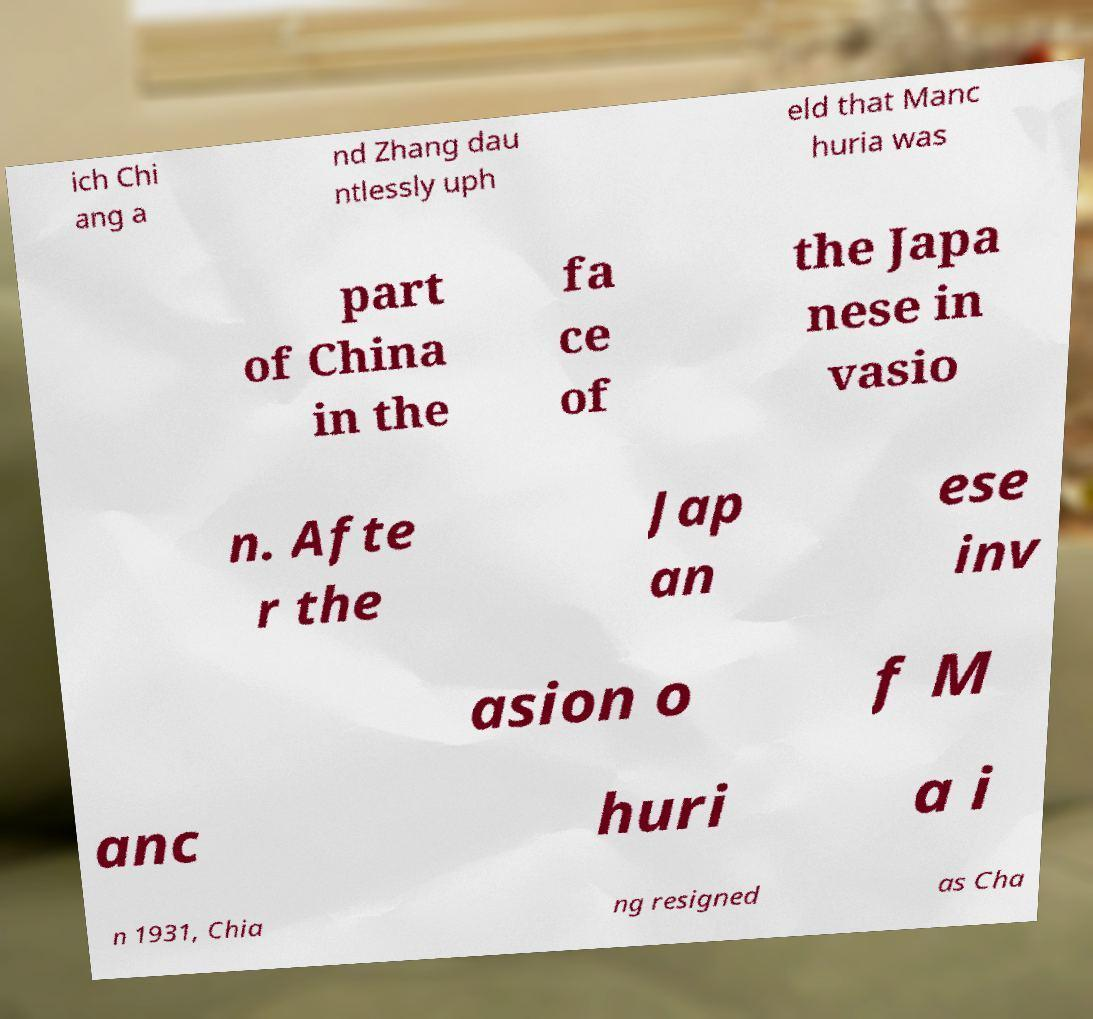What messages or text are displayed in this image? I need them in a readable, typed format. ich Chi ang a nd Zhang dau ntlessly uph eld that Manc huria was part of China in the fa ce of the Japa nese in vasio n. Afte r the Jap an ese inv asion o f M anc huri a i n 1931, Chia ng resigned as Cha 